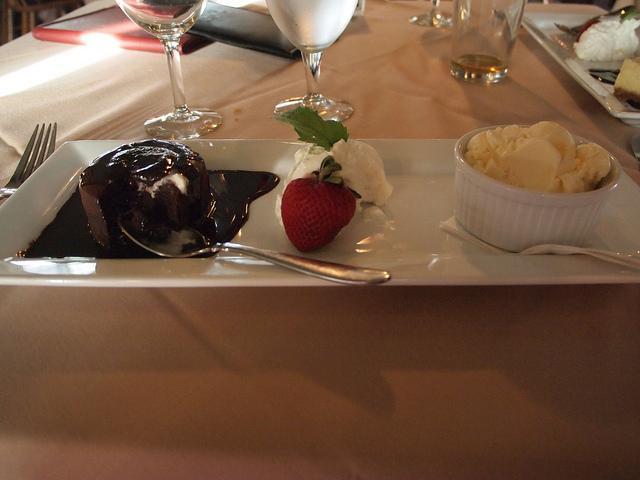How many ice cream bowls?
Give a very brief answer. 1. How many wine glasses are there?
Give a very brief answer. 2. 